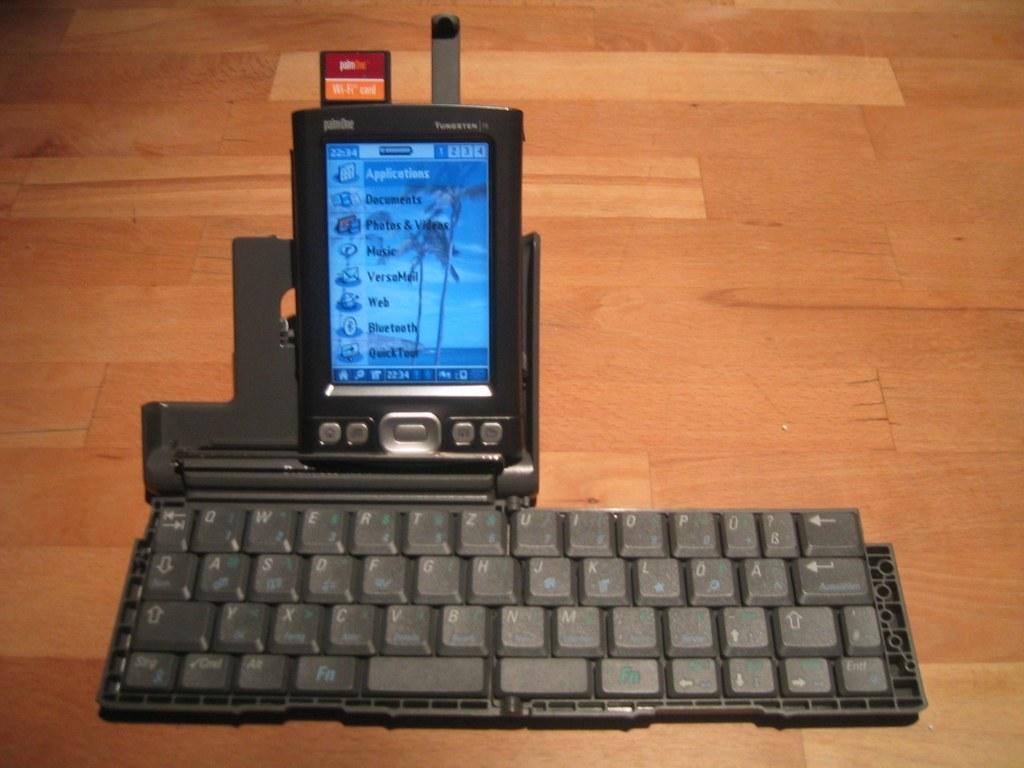What type of phone is this?
Offer a very short reply. Panasonic. What is the first word on the phone screen?
Your answer should be compact. Applications. 